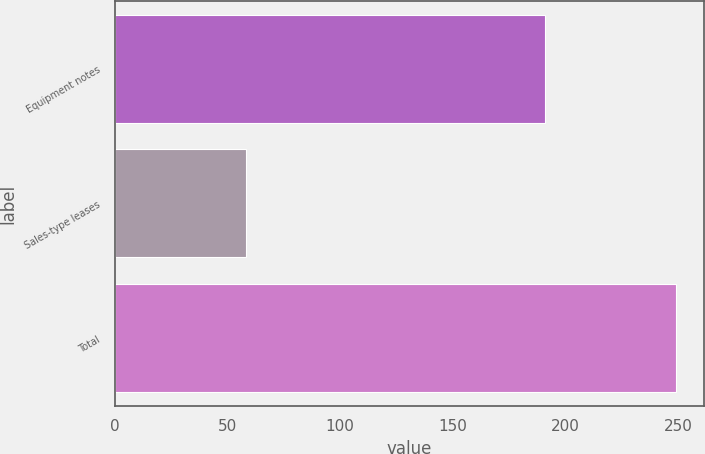Convert chart. <chart><loc_0><loc_0><loc_500><loc_500><bar_chart><fcel>Equipment notes<fcel>Sales-type leases<fcel>Total<nl><fcel>191<fcel>58<fcel>249<nl></chart> 